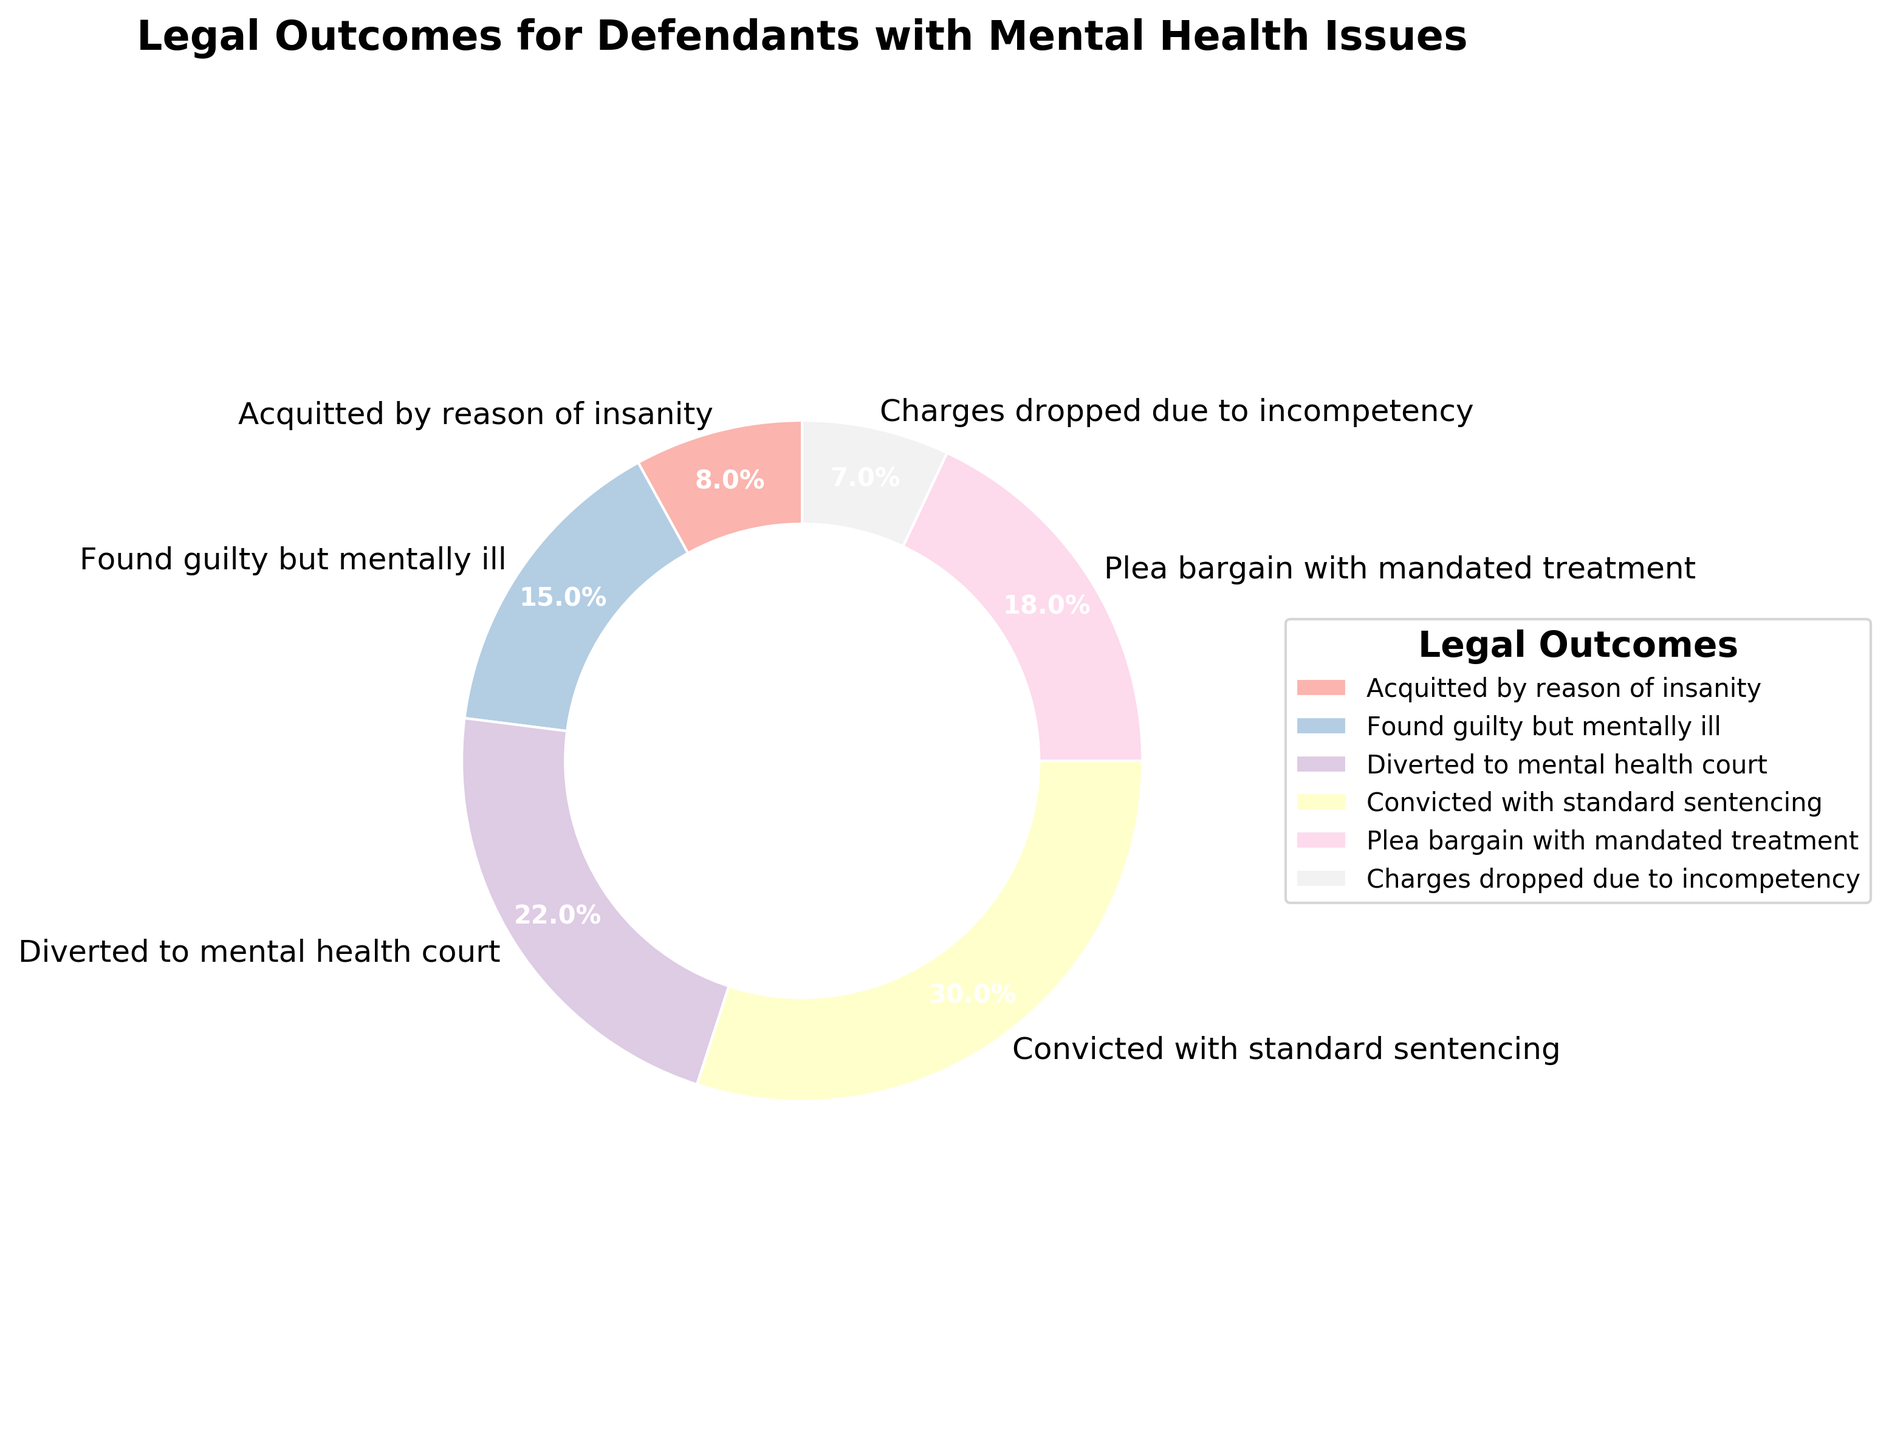What proportion of defendants were found guilty but mentally ill? According to the pie chart, the proportion of defendants who were found guilty but mentally ill is indicated.
Answer: 15% Which legal outcome has the highest proportion? By looking at the pie chart, we can see that the segment representing "Convicted with standard sentencing" is the largest.
Answer: Convicted with standard sentencing Do more defendants receive a plea bargain with mandated treatment or get acquitted by reason of insanity? Compare the segments for the two legal outcomes "Plea bargain with mandated treatment" (18%) and "Acquitted by reason of insanity" (8%).
Answer: Plea bargain with mandated treatment Which legal outcome is represented by the purple segment? The pie chart segments are color-coded; identify the purple segment and see the corresponding label.
Answer: Diverted to mental health court What is the combined proportion of defendants who either had their charges dropped due to incompetency or were acquitted by reason of insanity? Add the percentages of the segments "Charges dropped due to incompetency" (7%) and "Acquitted by reason of insanity" (8%). 7% + 8% = 15%
Answer: 15% What is the difference in proportion between defendants diverted to mental health court and those convicted with standard sentencing? Subtract the proportion of "Diverted to mental health court" (22%) from "Convicted with standard sentencing" (30%). 30% - 22% = 8%
Answer: 8% Which group constitutes a larger proportion, those found guilty but mentally ill or those receiving a plea bargain with mandated treatment? Compare the percentages for "Found guilty but mentally ill" (15%) and "Plea bargain with mandated treatment" (18%).
Answer: Plea bargain with mandated treatment What is the average proportion of 'Convicted with standard sentencing' and 'Plea bargain with mandated treatment'? Add the proportions and divide by 2. (30% + 18%)/2 = 24%
Answer: 24% How many legal outcomes have a proportion higher than 10%? Identify and count the segments with proportions above 10%: Found guilty but mentally ill (15%), Diverted to mental health court (22%), Convicted with standard sentencing (30%), and Plea bargain with mandated treatment (18%).
Answer: 4 